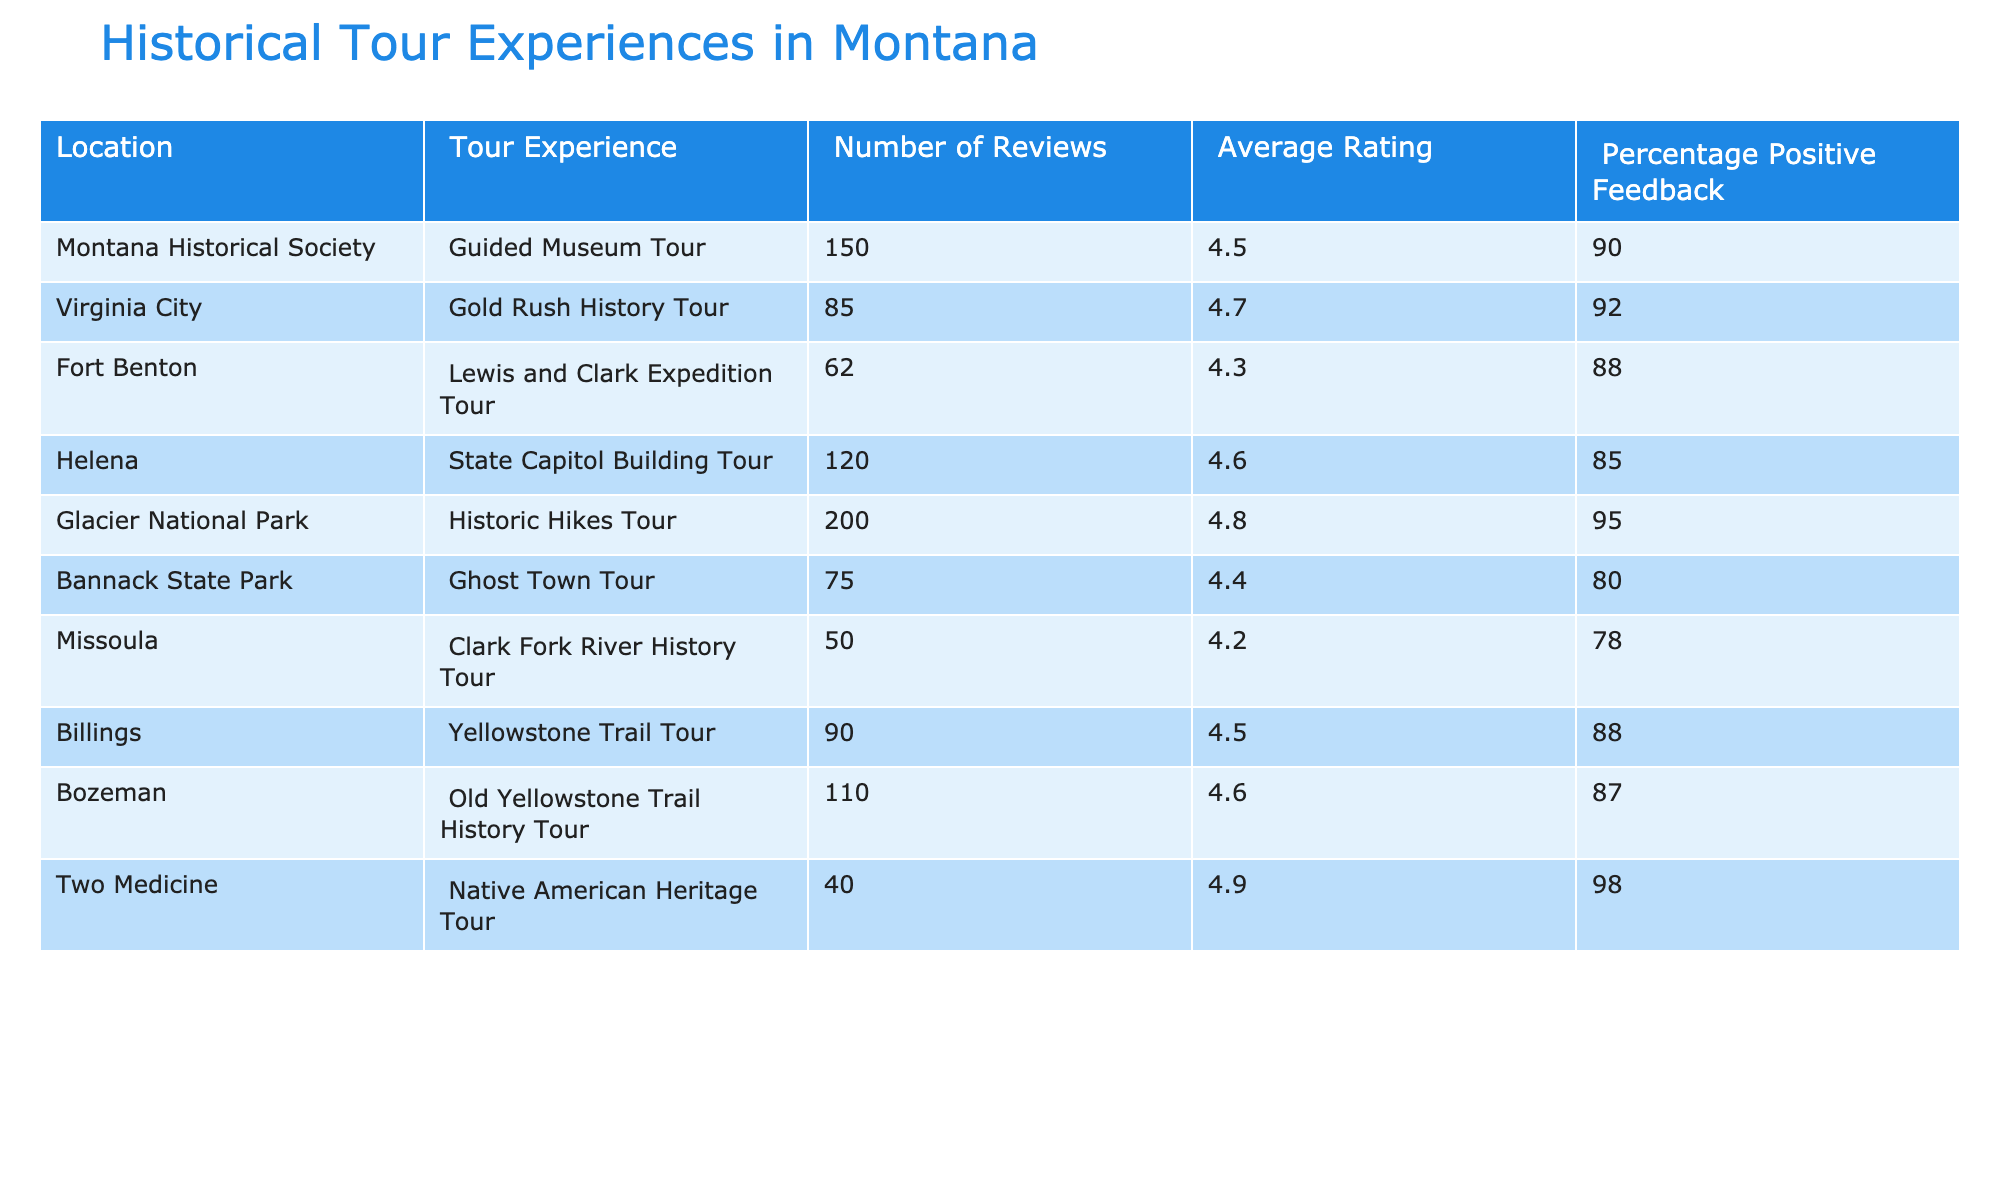What is the location with the highest average rating? Looking at the Average Rating column, the highest value is 4.9, which corresponds to the Two Medicine location.
Answer: Two Medicine How many reviews were submitted for the Glacier National Park tour? The Number of Reviews column shows that Glacier National Park received 200 reviews.
Answer: 200 What is the percentage of positive feedback for the guided museum tour? The percentage positive feedback for the Montana Historical Society guided museum tour is listed as 90%.
Answer: 90% Which tour experience has the lowest number of reviews? By reviewing the Number of Reviews column, Missoula's Clark Fork River History Tour has the lowest with 50 reviews.
Answer: Missoula, Clark Fork River History Tour Is the average rating for Virginia City's Gold Rush History Tour above 4.5? Virginia City has an average rating of 4.7, which is indeed above 4.5.
Answer: Yes What is the average of the positive feedback percentages for all the tours listed? Adding the percentage positive feedback values: 90 + 92 + 88 + 85 + 95 + 80 + 78 + 88 + 87 + 98 gives 901. Dividing by 10 (the number of tours), the average is 90.1%.
Answer: 90.1% Which tour has a higher average rating: the Guided Museum Tour or the Ghost Town Tour? The Guided Museum Tour has an average rating of 4.5, while the Ghost Town Tour has a rating of 4.4. Therefore, the Guided Museum Tour has a higher rating.
Answer: Guided Museum Tour What is the difference in percentage positive feedback between the highest and lowest scoring tours? The highest percentage positive feedback is 98% for Two Medicine, and the lowest is 78% for Missoula. The difference is 98% - 78% = 20%.
Answer: 20% How many tours have an average rating of 4.5 or higher? The tours with an average rating of 4.5 or higher are: Guided Museum Tour, Gold Rush History Tour, State Capitol Building Tour, Historic Hikes Tour, Yellowstone Trail Tour, Old Yellowstone Trail History Tour, and Native American Heritage Tour. That gives us 7 tours.
Answer: 7 